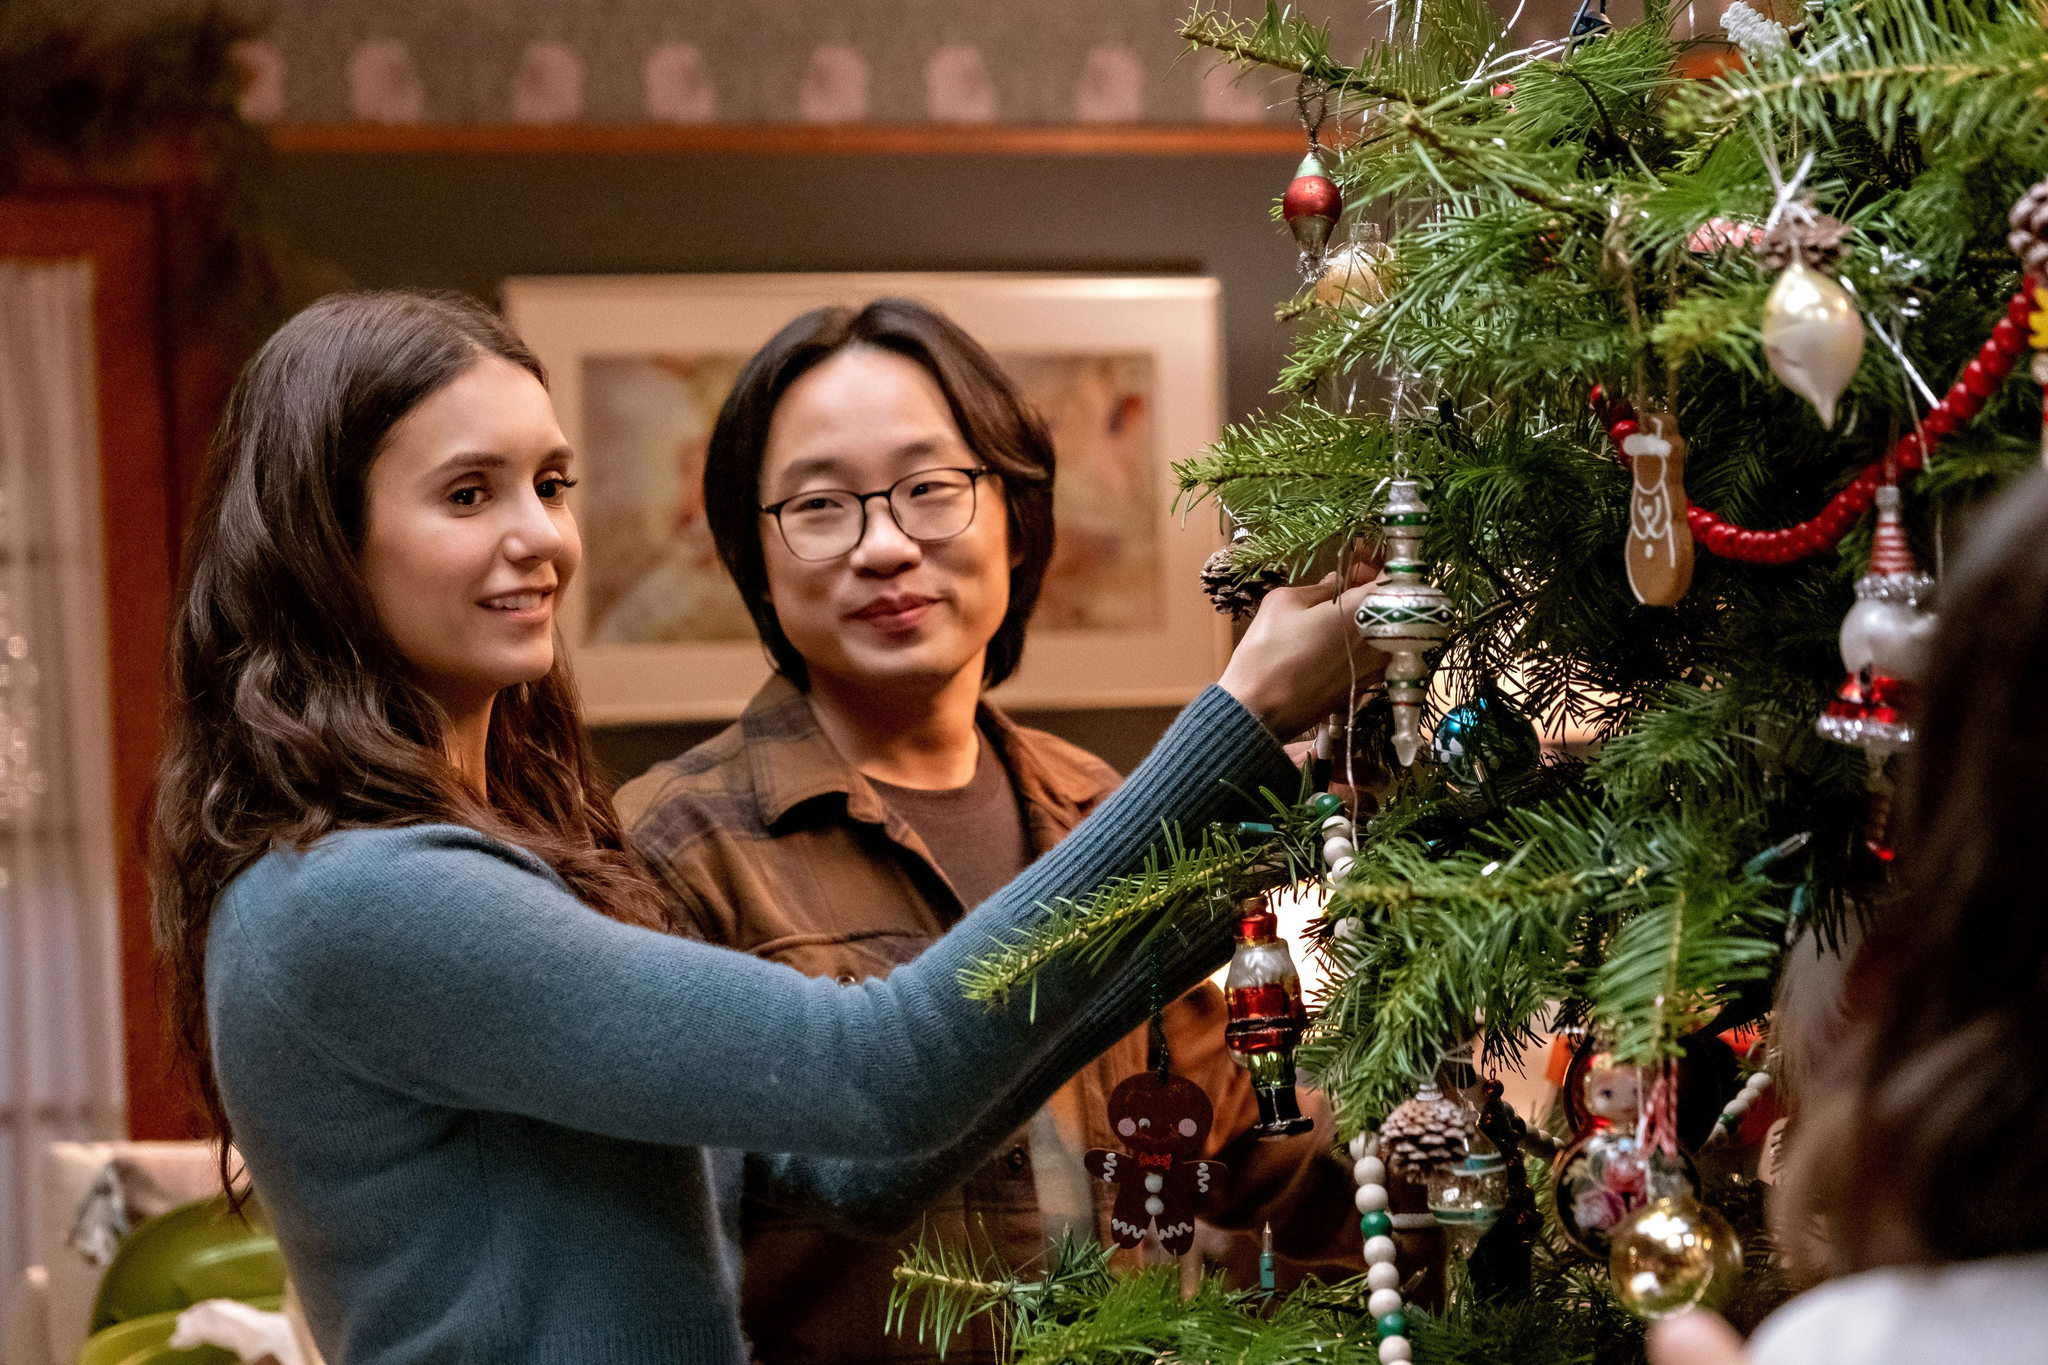Tell me about the decorations on the Christmas tree. The Christmas tree in the image is beautifully decorated with a variety of ornaments. Some notable decorations include classic red and gold balls, intricate white snowflakes, a cute gingerbread man, and other assorted festive items. The combination of these ornaments creates a traditional yet lively holiday vibe, perfect for the cozy setting of the living room backdrop. Is there a standout ornament on the tree that catches the eye? Yes, one ornament that particularly catches the eye is a charming gingerbread man. Positioned prominently, it adds a playful and whimsical touch to the tree's decor. Its cheerful design seems to invite a sense of fun and nostalgia, standing out amidst the more classic red and gold balls and the delicate white snowflakes. Imagine if that tree had magical ornaments, what kind of magic would they have? Imagine if the ornaments on this tree had magical properties! The gingerbread man could come to life, spreading holiday cheer by dancing and singing festive songs. The red and gold balls might glow softly, casting a warm and soothing light throughout the room. The white snowflakes could conjure gentle snowfall indoors, creating a serene winter wonderland without the chill. Each ornament would have its unique enchantment, perhaps even whispering stories of holiday traditions and tales from around the world. The tree would become a centerpiece of magical joy, bringing the spirit of the season to life in the most whimsical ways. 